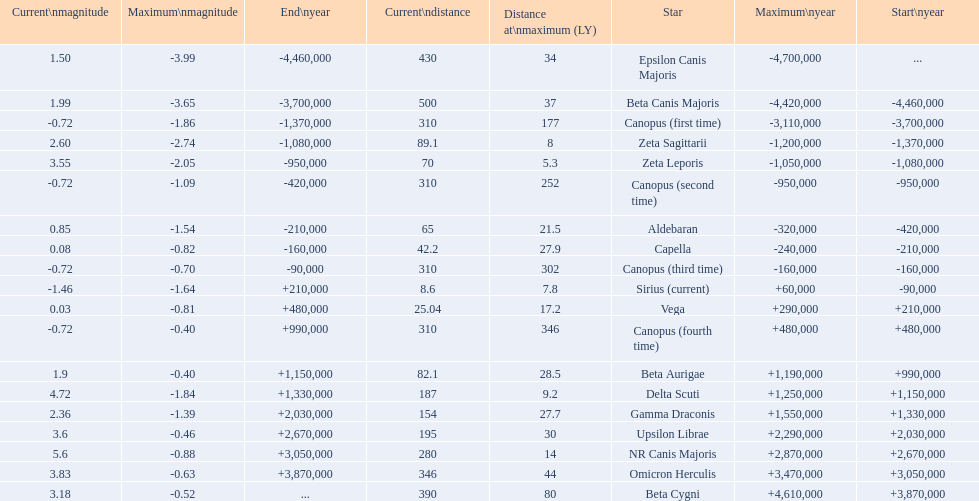What is the number of stars that have a maximum magnitude less than zero? 5. 